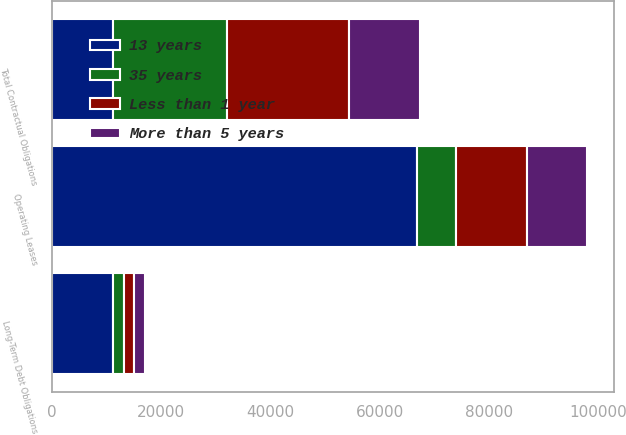<chart> <loc_0><loc_0><loc_500><loc_500><stacked_bar_chart><ecel><fcel>Operating Leases<fcel>Long-Term Debt Obligations<fcel>Total Contractual Obligations<nl><fcel>13 years<fcel>66861<fcel>11199<fcel>11199<nl><fcel>35 years<fcel>7071<fcel>1977<fcel>20910<nl><fcel>Less than 1 year<fcel>13103<fcel>1977<fcel>22243<nl><fcel>More than 5 years<fcel>10857<fcel>1977<fcel>13034<nl></chart> 